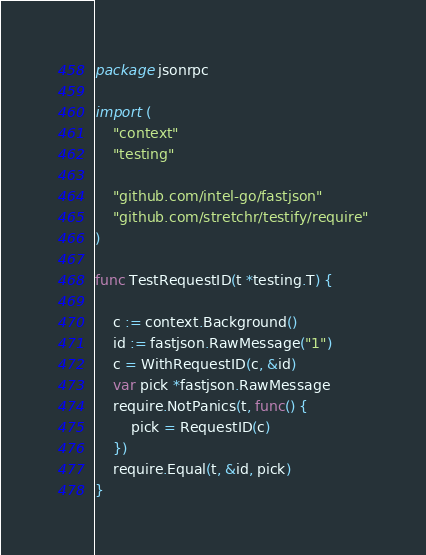<code> <loc_0><loc_0><loc_500><loc_500><_Go_>package jsonrpc

import (
	"context"
	"testing"

	"github.com/intel-go/fastjson"
	"github.com/stretchr/testify/require"
)

func TestRequestID(t *testing.T) {

	c := context.Background()
	id := fastjson.RawMessage("1")
	c = WithRequestID(c, &id)
	var pick *fastjson.RawMessage
	require.NotPanics(t, func() {
		pick = RequestID(c)
	})
	require.Equal(t, &id, pick)
}
</code> 